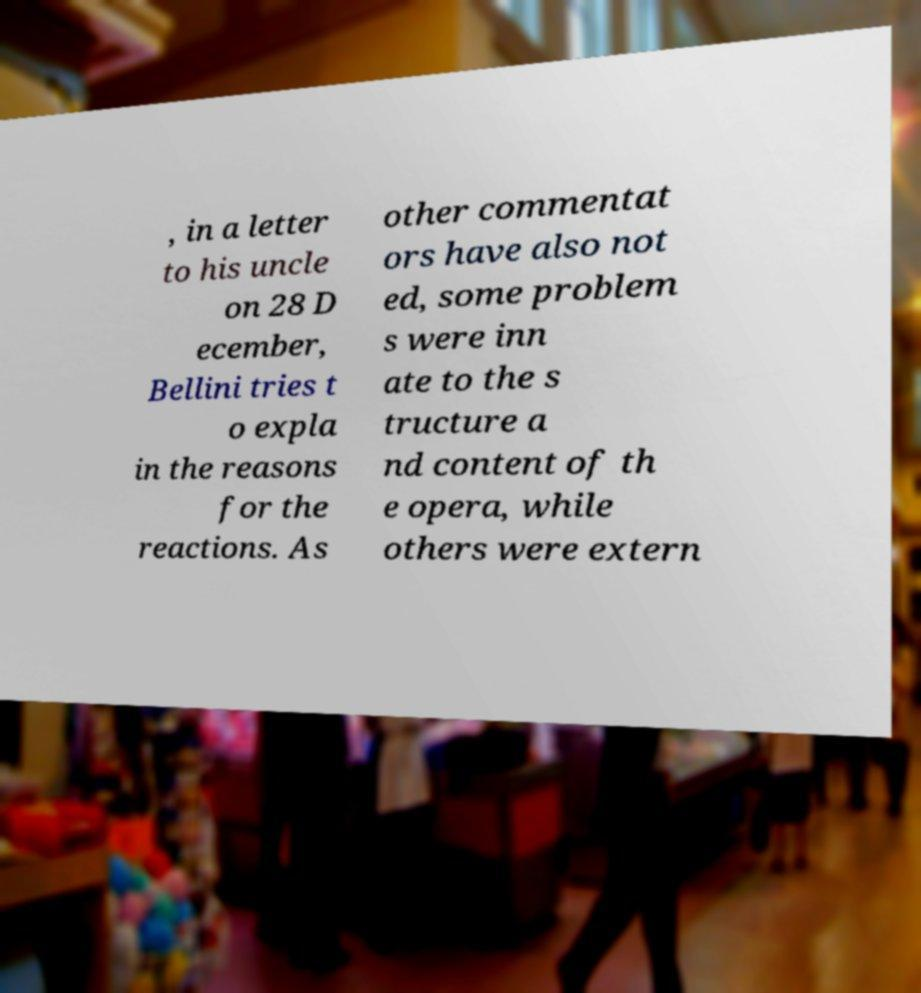For documentation purposes, I need the text within this image transcribed. Could you provide that? , in a letter to his uncle on 28 D ecember, Bellini tries t o expla in the reasons for the reactions. As other commentat ors have also not ed, some problem s were inn ate to the s tructure a nd content of th e opera, while others were extern 